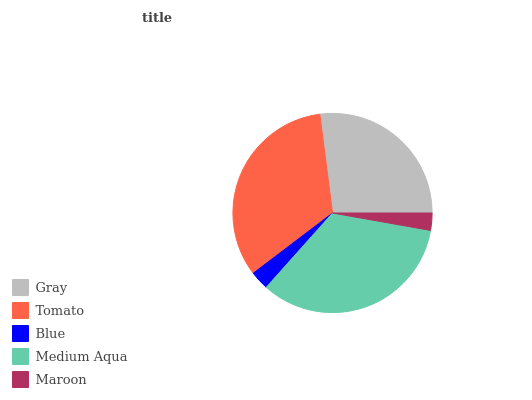Is Maroon the minimum?
Answer yes or no. Yes. Is Medium Aqua the maximum?
Answer yes or no. Yes. Is Tomato the minimum?
Answer yes or no. No. Is Tomato the maximum?
Answer yes or no. No. Is Tomato greater than Gray?
Answer yes or no. Yes. Is Gray less than Tomato?
Answer yes or no. Yes. Is Gray greater than Tomato?
Answer yes or no. No. Is Tomato less than Gray?
Answer yes or no. No. Is Gray the high median?
Answer yes or no. Yes. Is Gray the low median?
Answer yes or no. Yes. Is Maroon the high median?
Answer yes or no. No. Is Tomato the low median?
Answer yes or no. No. 